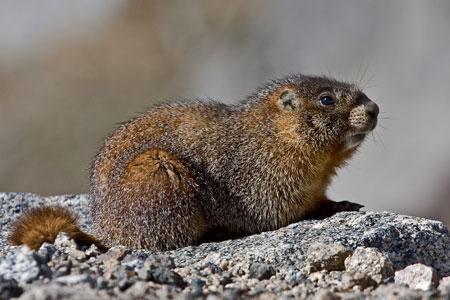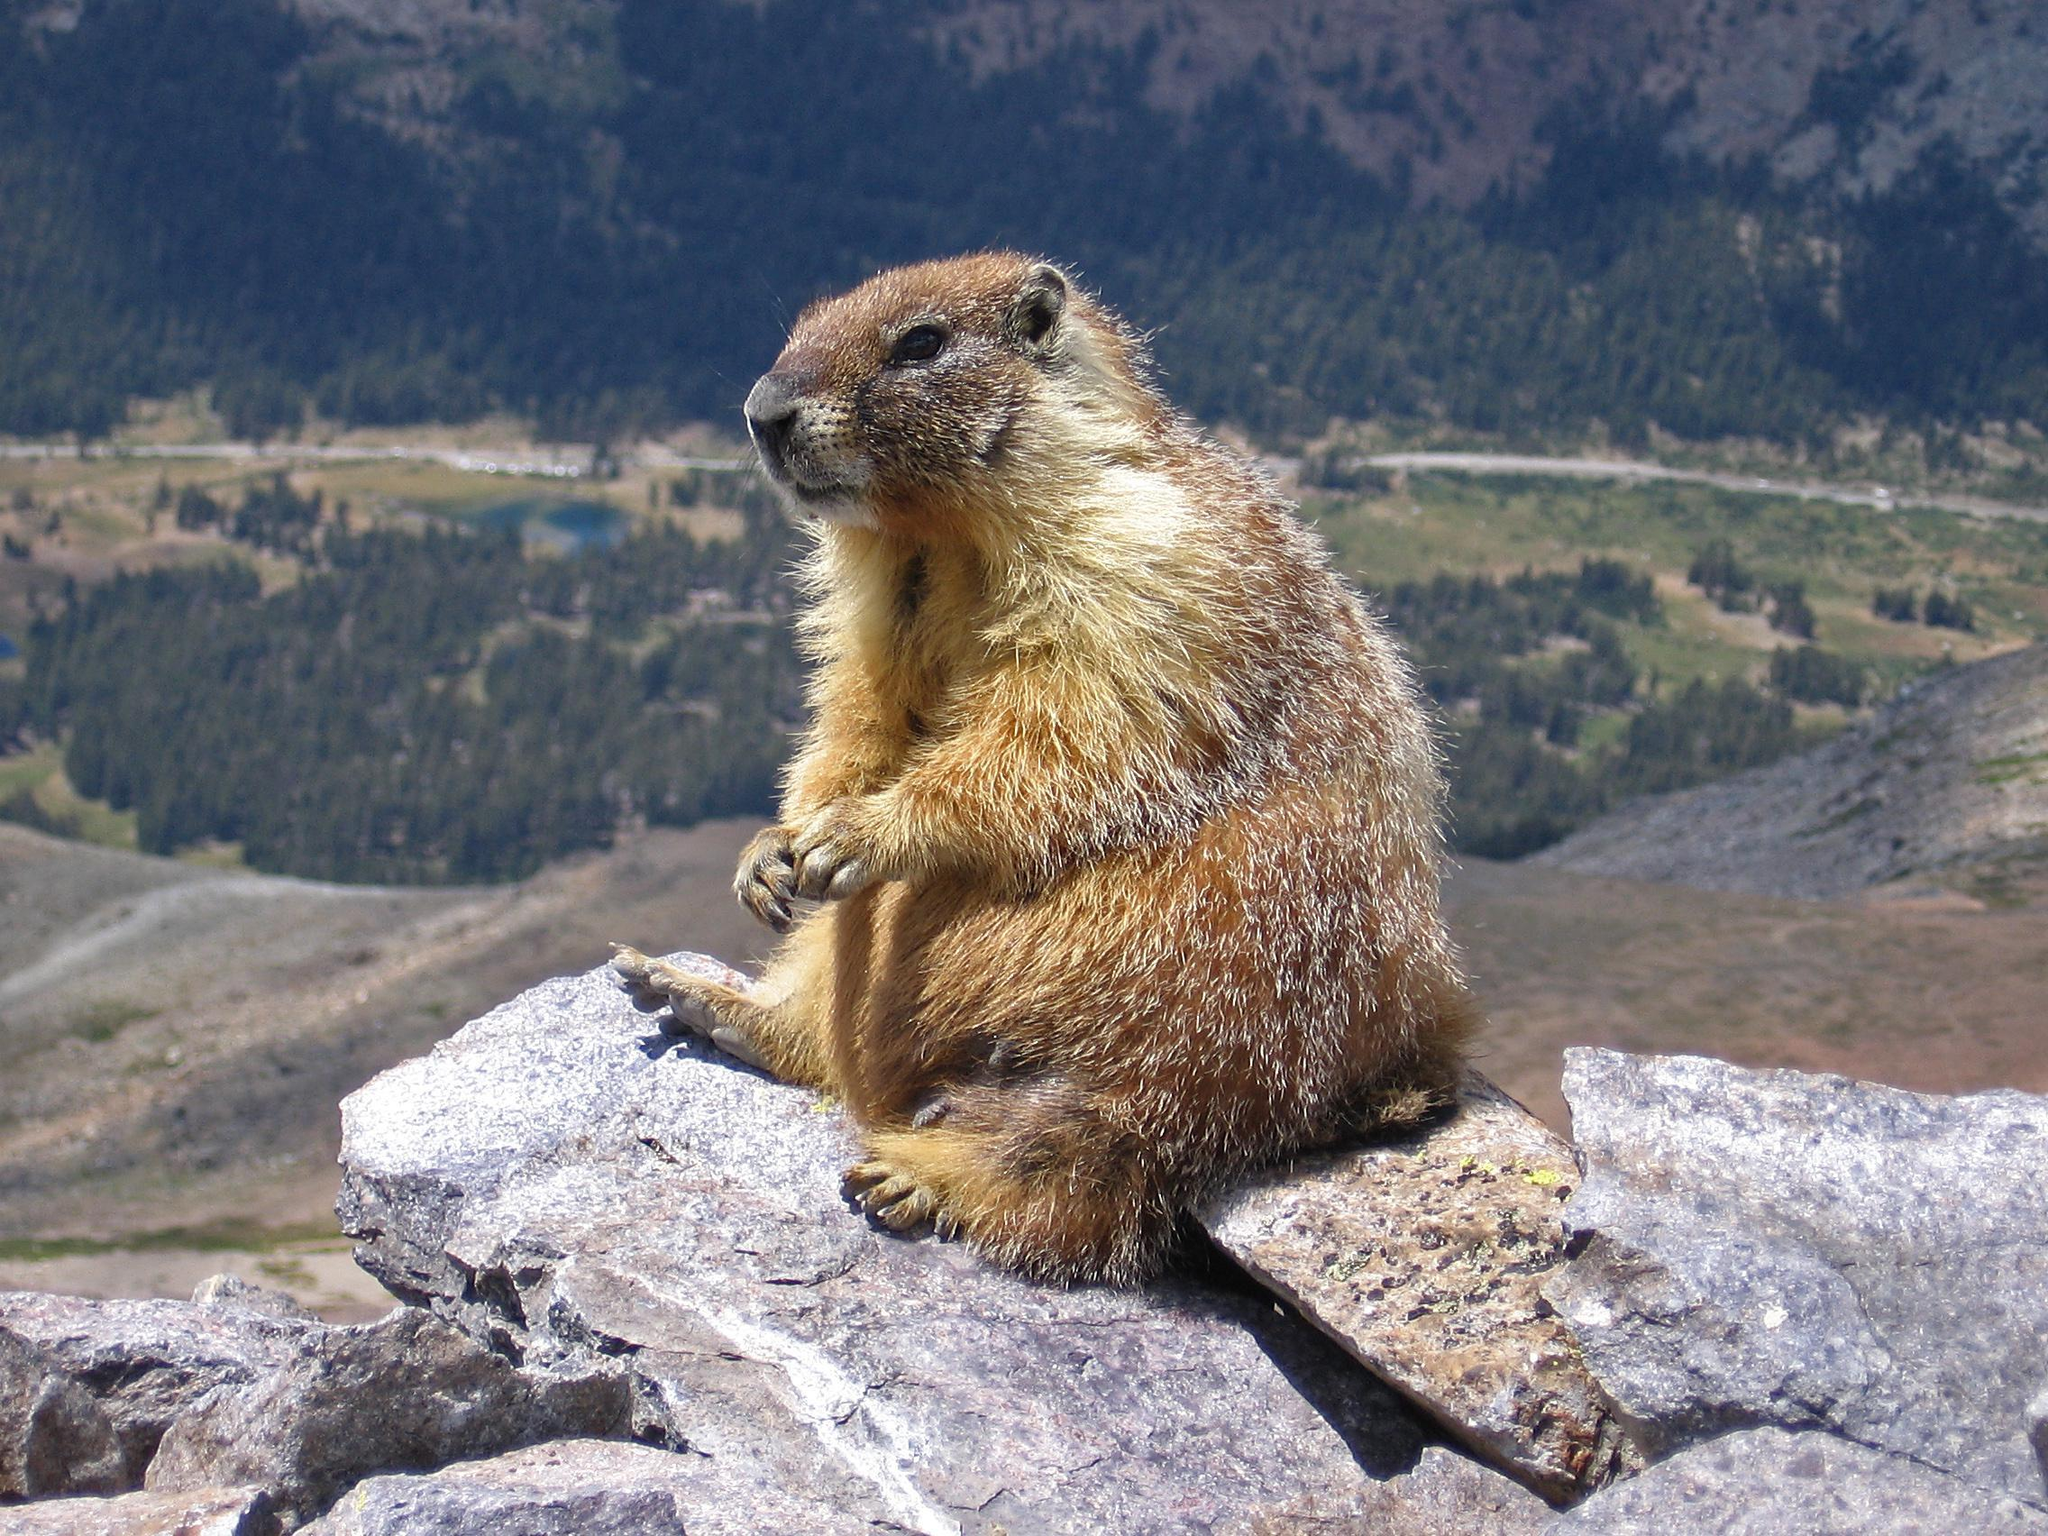The first image is the image on the left, the second image is the image on the right. Given the left and right images, does the statement "The animal in the image on the right is not touching the ground with its front paws." hold true? Answer yes or no. Yes. 